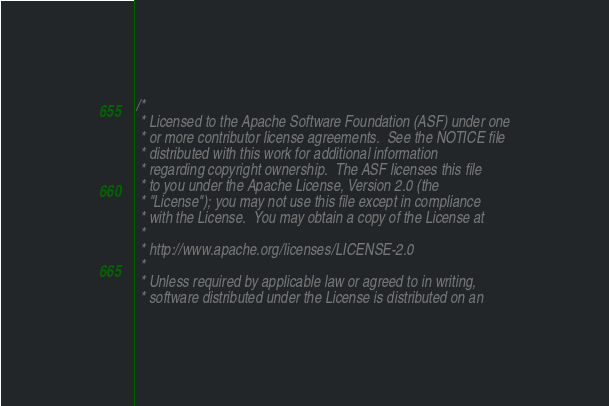<code> <loc_0><loc_0><loc_500><loc_500><_SQL_>/*
 * Licensed to the Apache Software Foundation (ASF) under one
 * or more contributor license agreements.  See the NOTICE file
 * distributed with this work for additional information
 * regarding copyright ownership.  The ASF licenses this file
 * to you under the Apache License, Version 2.0 (the
 * "License"); you may not use this file except in compliance
 * with the License.  You may obtain a copy of the License at
 *
 * http://www.apache.org/licenses/LICENSE-2.0
 *
 * Unless required by applicable law or agreed to in writing,
 * software distributed under the License is distributed on an</code> 